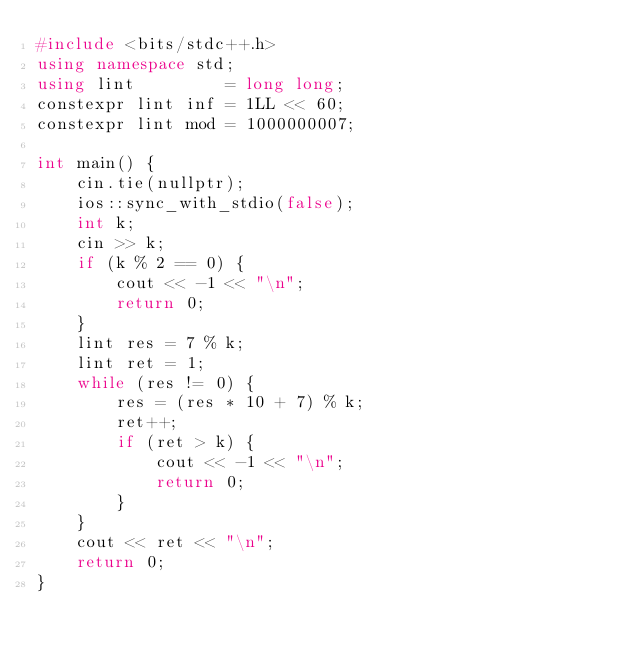Convert code to text. <code><loc_0><loc_0><loc_500><loc_500><_C++_>#include <bits/stdc++.h>
using namespace std;
using lint         = long long;
constexpr lint inf = 1LL << 60;
constexpr lint mod = 1000000007;

int main() {
    cin.tie(nullptr);
    ios::sync_with_stdio(false);
    int k;
    cin >> k;
    if (k % 2 == 0) {
        cout << -1 << "\n";
        return 0;
    }
    lint res = 7 % k;
    lint ret = 1;
    while (res != 0) {
        res = (res * 10 + 7) % k;
        ret++;
        if (ret > k) {
            cout << -1 << "\n";
            return 0;
        }
    }
    cout << ret << "\n";
    return 0;
}</code> 